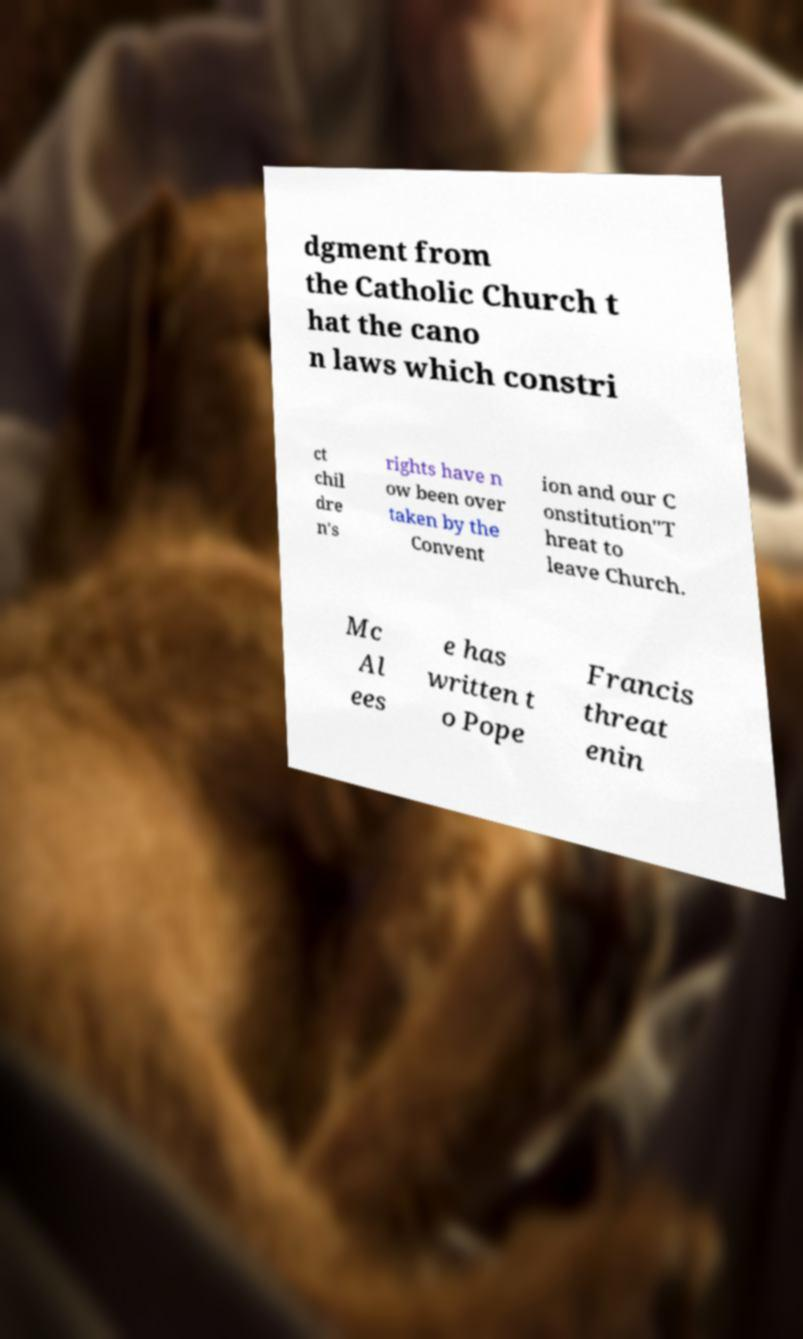Can you read and provide the text displayed in the image?This photo seems to have some interesting text. Can you extract and type it out for me? dgment from the Catholic Church t hat the cano n laws which constri ct chil dre n's rights have n ow been over taken by the Convent ion and our C onstitution"T hreat to leave Church. Mc Al ees e has written t o Pope Francis threat enin 